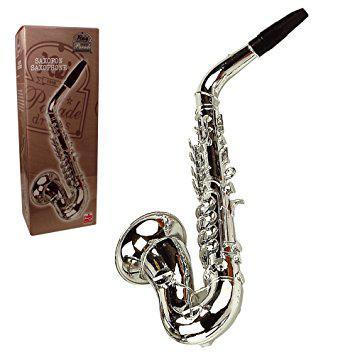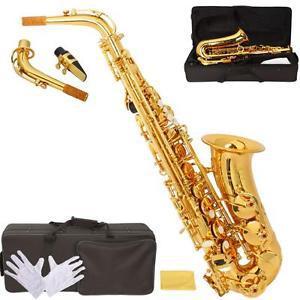The first image is the image on the left, the second image is the image on the right. For the images displayed, is the sentence "Each image shows just one saxophone that is out of its case." factually correct? Answer yes or no. Yes. The first image is the image on the left, the second image is the image on the right. For the images displayed, is the sentence "There are the same number of saxophones in each of the images." factually correct? Answer yes or no. Yes. 